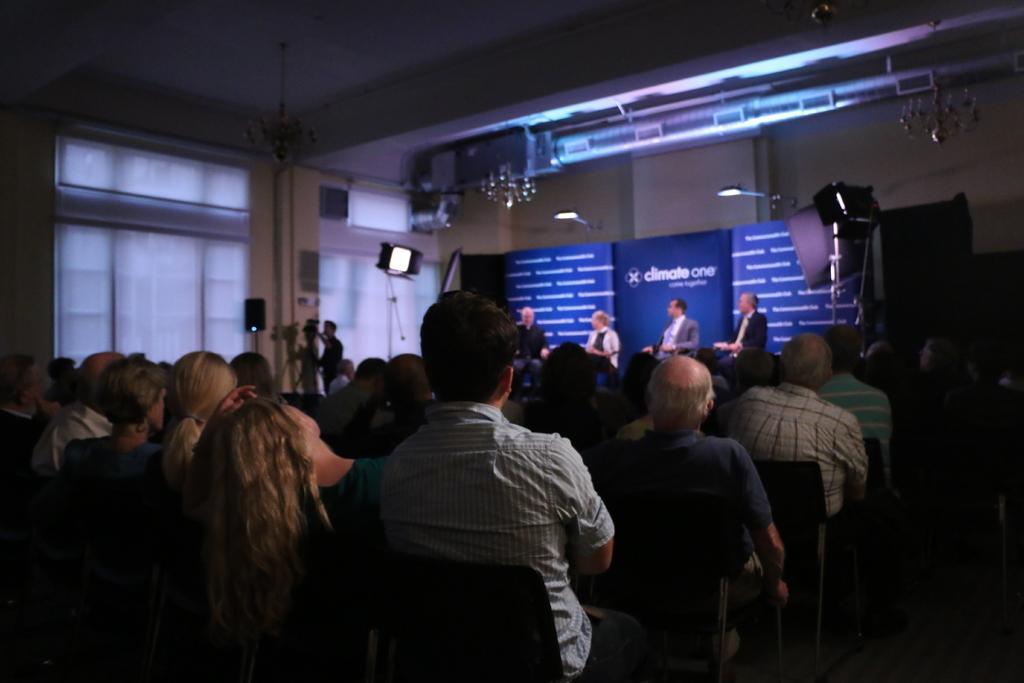In one or two sentences, can you explain what this image depicts? In this image there are a group of people sitting, and in the background there are some persons, boards, cameras, lights, speakers, poles and there are windows and wall. At the top there is ceiling and one chandelier, in the center there is a pole and some objects. 